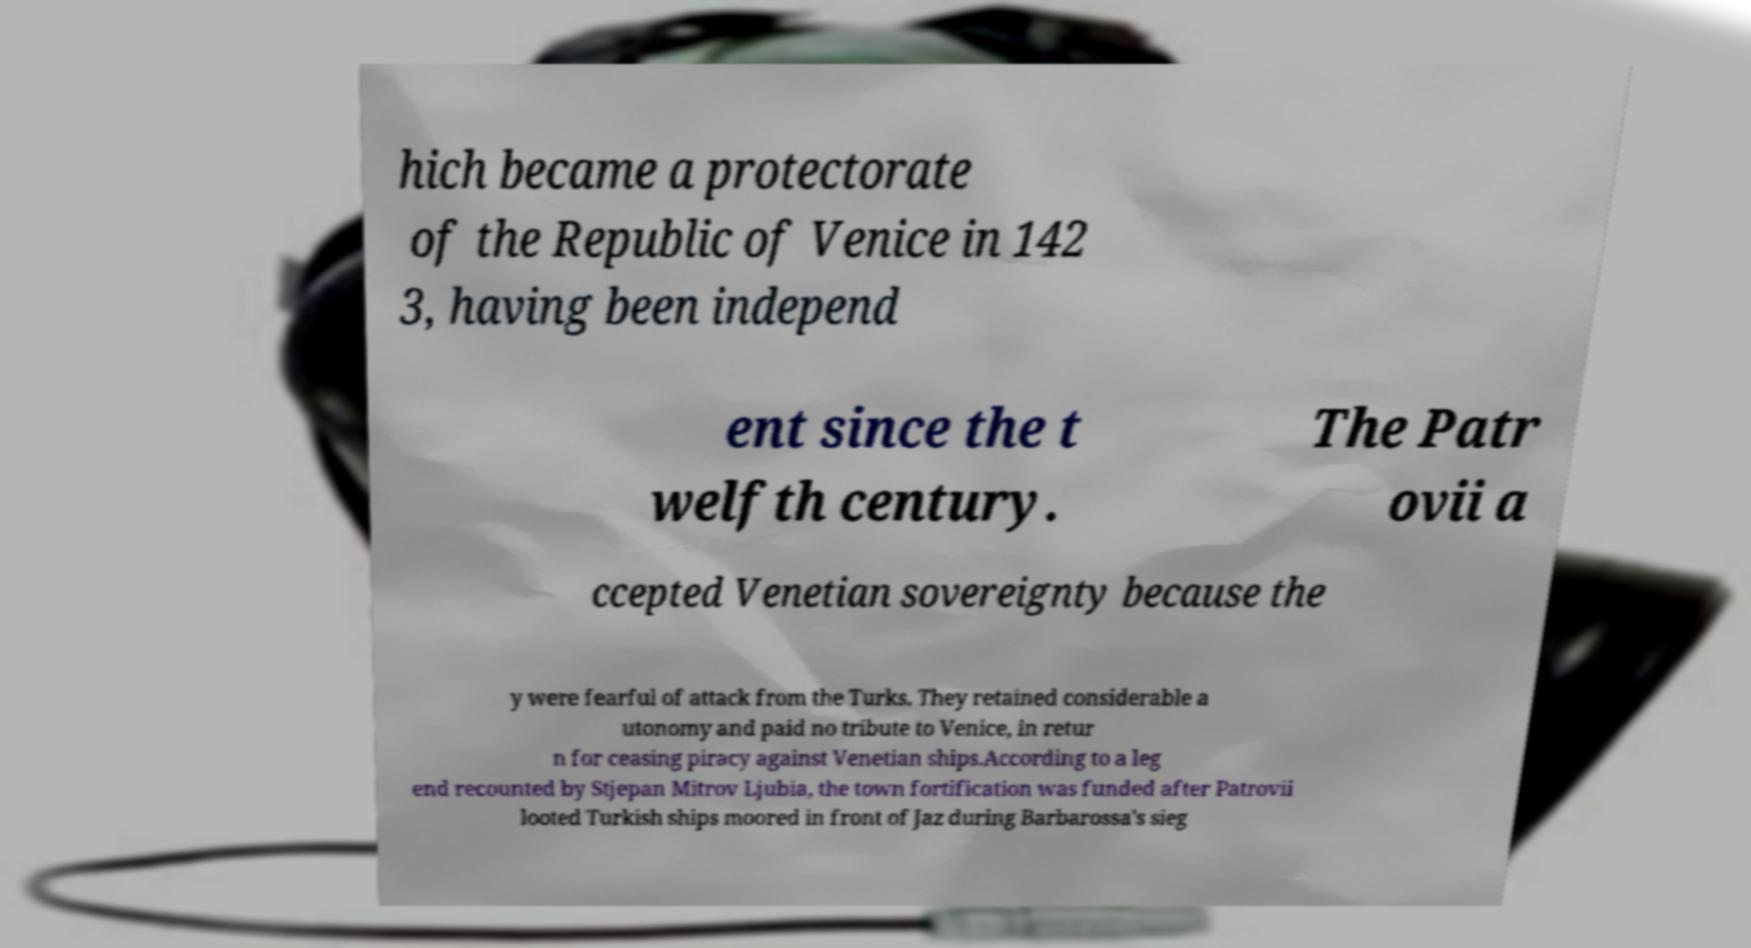There's text embedded in this image that I need extracted. Can you transcribe it verbatim? hich became a protectorate of the Republic of Venice in 142 3, having been independ ent since the t welfth century. The Patr ovii a ccepted Venetian sovereignty because the y were fearful of attack from the Turks. They retained considerable a utonomy and paid no tribute to Venice, in retur n for ceasing piracy against Venetian ships.According to a leg end recounted by Stjepan Mitrov Ljubia, the town fortification was funded after Patrovii looted Turkish ships moored in front of Jaz during Barbarossa's sieg 